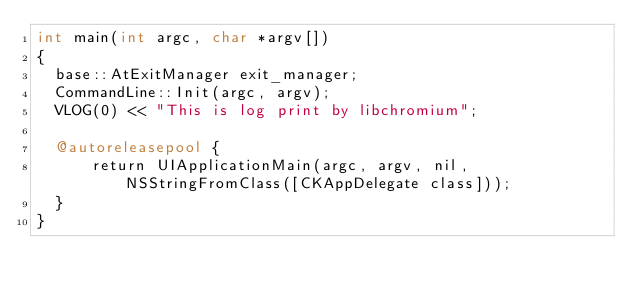Convert code to text. <code><loc_0><loc_0><loc_500><loc_500><_ObjectiveC_>int main(int argc, char *argv[])
{
  base::AtExitManager exit_manager;
  CommandLine::Init(argc, argv);
  VLOG(0) << "This is log print by libchromium";
  
  @autoreleasepool {
      return UIApplicationMain(argc, argv, nil, NSStringFromClass([CKAppDelegate class]));
  }
}
</code> 